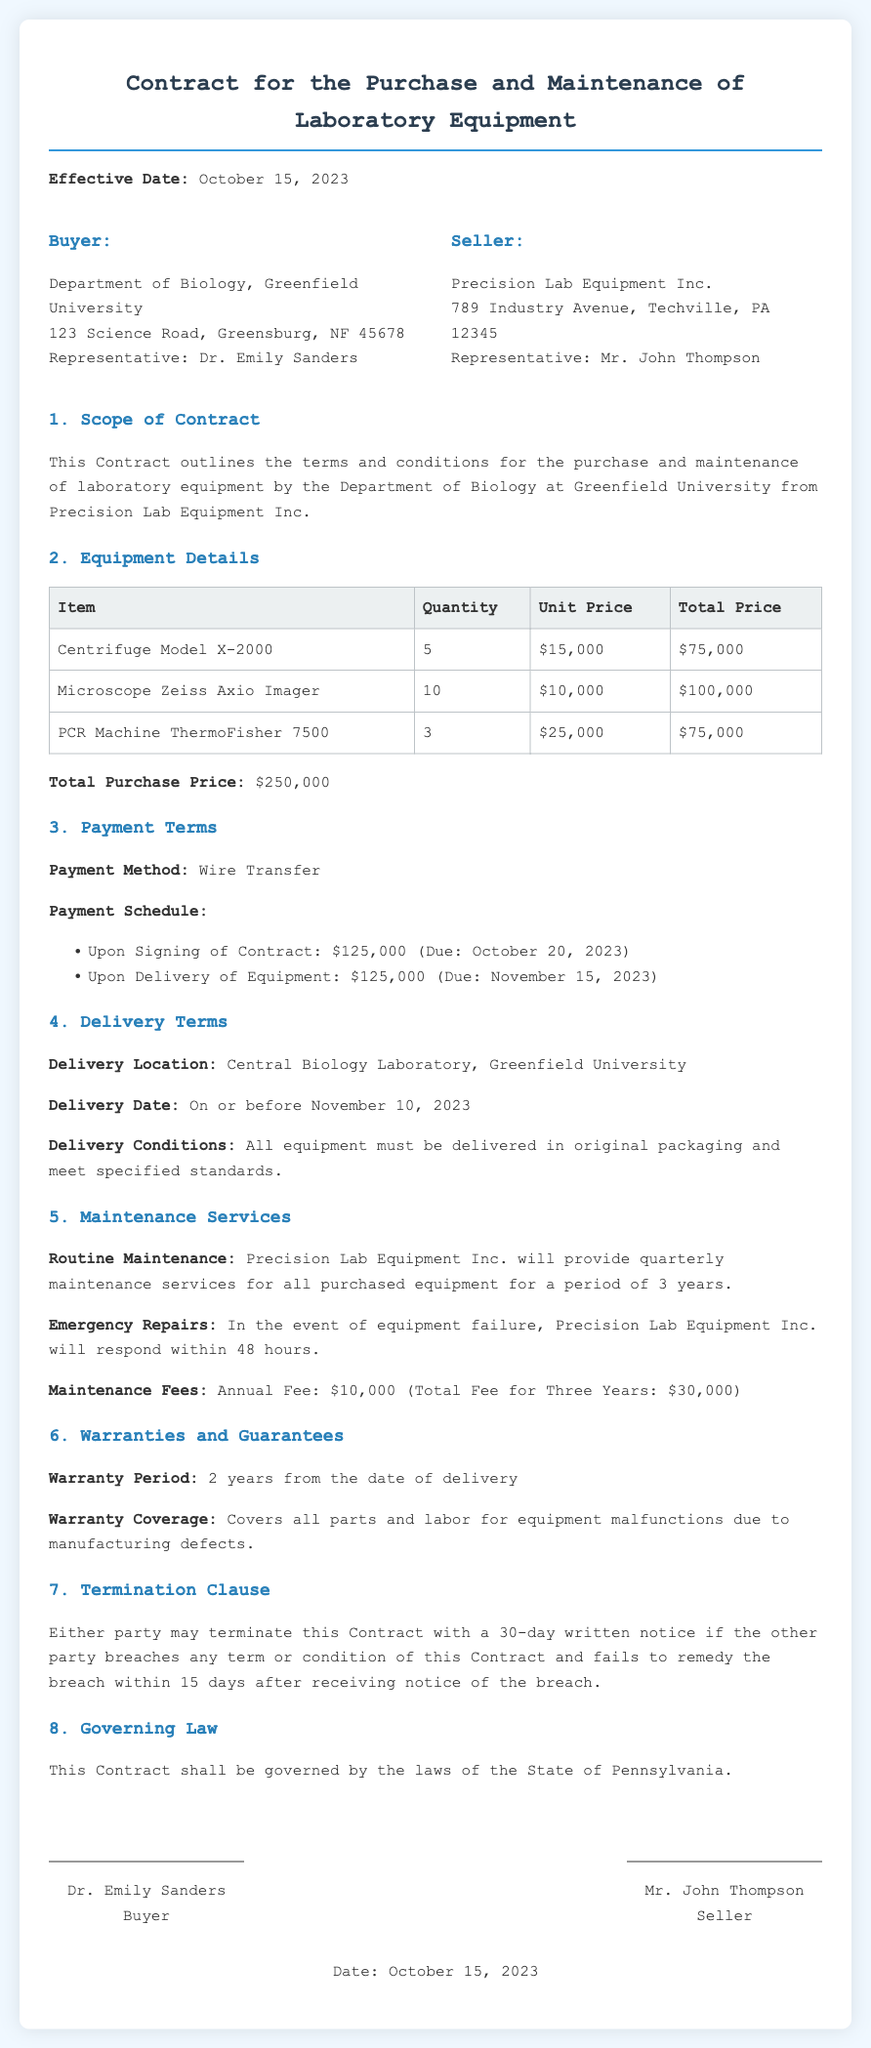what is the effective date of the contract? The effective date is stated as October 15, 2023, in the document.
Answer: October 15, 2023 who is the representative of the buyer? The document names Dr. Emily Sanders as the representative for the buyer.
Answer: Dr. Emily Sanders how many units of the Centrifuge Model X-2000 are being purchased? The number of units for the Centrifuge Model X-2000 is specified as 5 in the equipment details.
Answer: 5 what is the total purchase price of the equipment? The total purchase price is mentioned as $250,000 in the summary of payment details.
Answer: $250,000 what is the annual fee for maintenance services? The document states that the annual maintenance fee is $10,000.
Answer: $10,000 how long is the warranty period for the equipment? The warranty period is described as 2 years from the delivery date in the warranty section.
Answer: 2 years what is the payment method specified in the contract? The payment method outlined in the contract is wire transfer.
Answer: Wire Transfer when is the delivery date for the equipment? The delivery date is set to be on or before November 10, 2023, according to the delivery terms.
Answer: November 10, 2023 what is the termination notice period required? The termination clause indicates a 30-day written notice is required.
Answer: 30-day written notice 